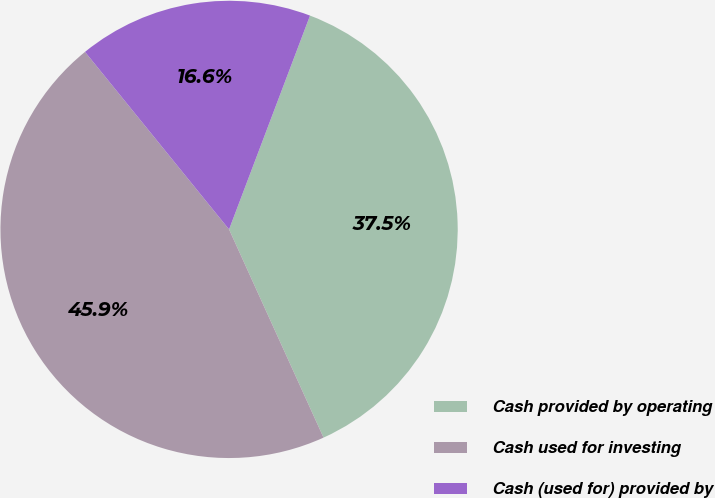Convert chart to OTSL. <chart><loc_0><loc_0><loc_500><loc_500><pie_chart><fcel>Cash provided by operating<fcel>Cash used for investing<fcel>Cash (used for) provided by<nl><fcel>37.46%<fcel>45.93%<fcel>16.61%<nl></chart> 